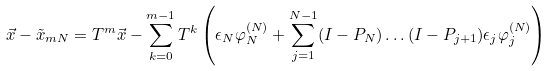<formula> <loc_0><loc_0><loc_500><loc_500>\vec { x } - \tilde { x } _ { m N } = T ^ { m } \vec { x } - \sum _ { k = 0 } ^ { m - 1 } T ^ { k } \left ( \epsilon _ { N } \varphi _ { N } ^ { ( N ) } + \sum _ { j = 1 } ^ { N - 1 } ( I - P _ { N } ) \dots ( I - P _ { j + 1 } ) \epsilon _ { j } \varphi _ { j } ^ { ( N ) } \right )</formula> 